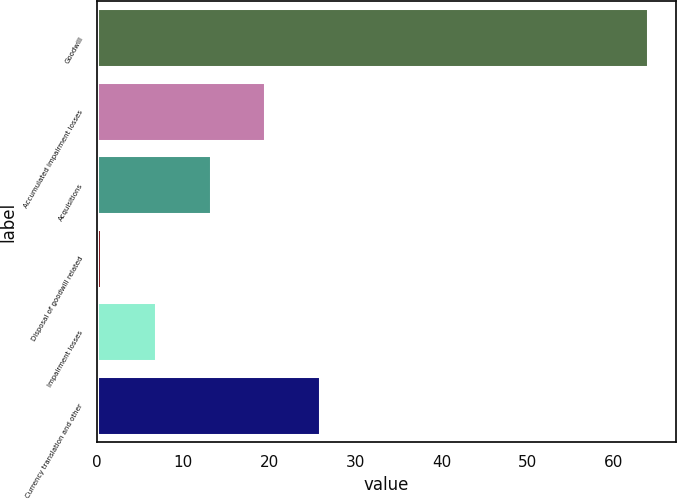Convert chart to OTSL. <chart><loc_0><loc_0><loc_500><loc_500><bar_chart><fcel>Goodwill<fcel>Accumulated impairment losses<fcel>Acquisitions<fcel>Disposal of goodwill related<fcel>Impairment losses<fcel>Currency translation and other<nl><fcel>64<fcel>19.52<fcel>13.16<fcel>0.45<fcel>6.81<fcel>25.88<nl></chart> 